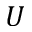<formula> <loc_0><loc_0><loc_500><loc_500>U</formula> 